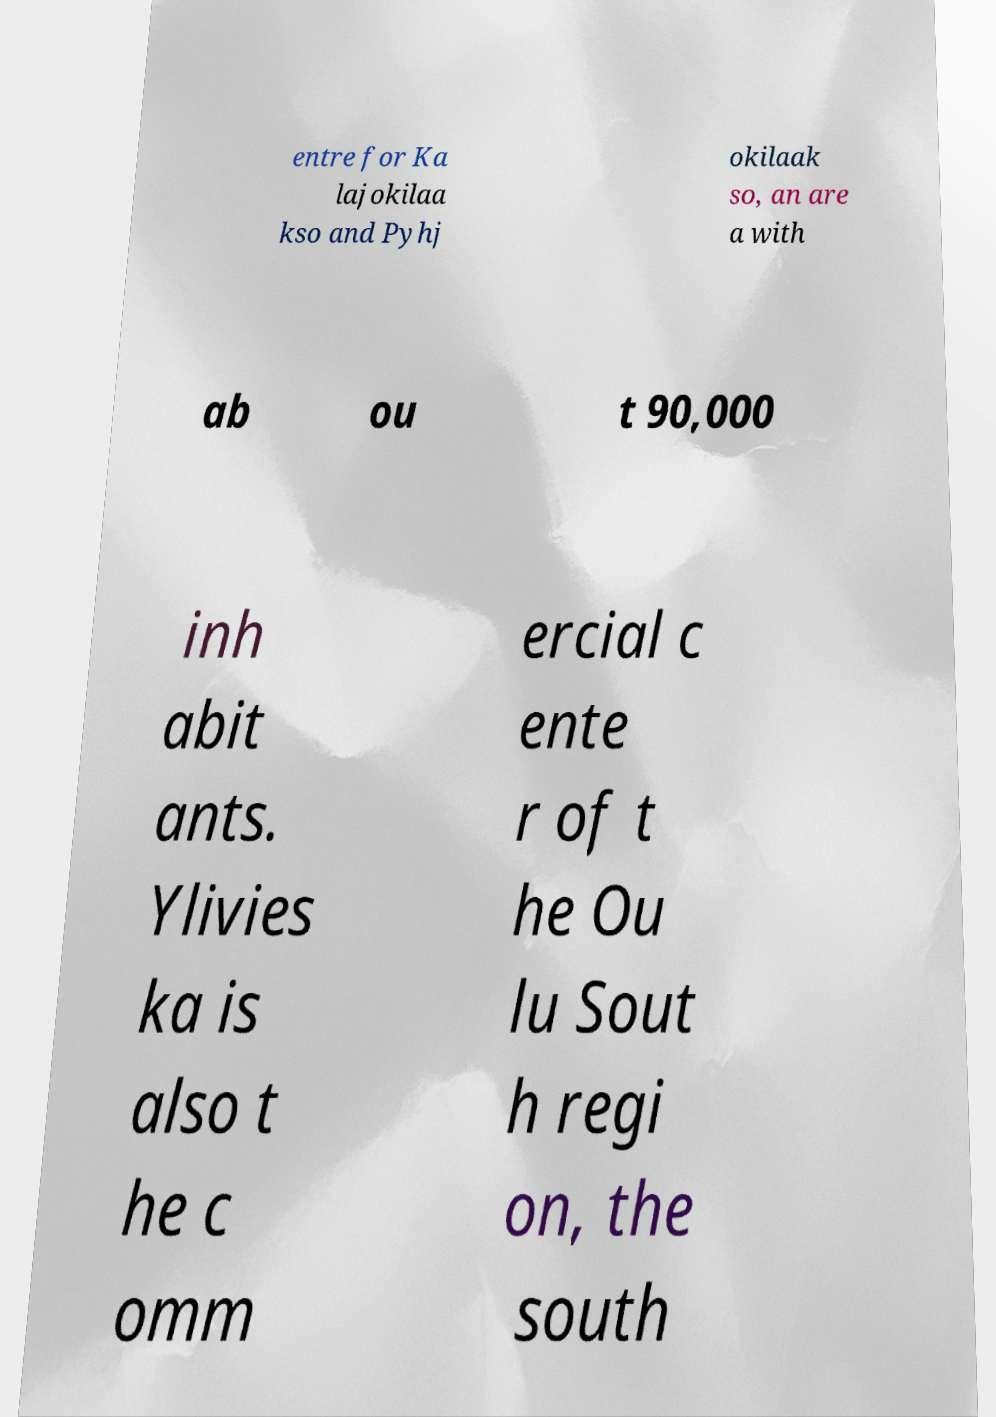Please read and relay the text visible in this image. What does it say? entre for Ka lajokilaa kso and Pyhj okilaak so, an are a with ab ou t 90,000 inh abit ants. Ylivies ka is also t he c omm ercial c ente r of t he Ou lu Sout h regi on, the south 